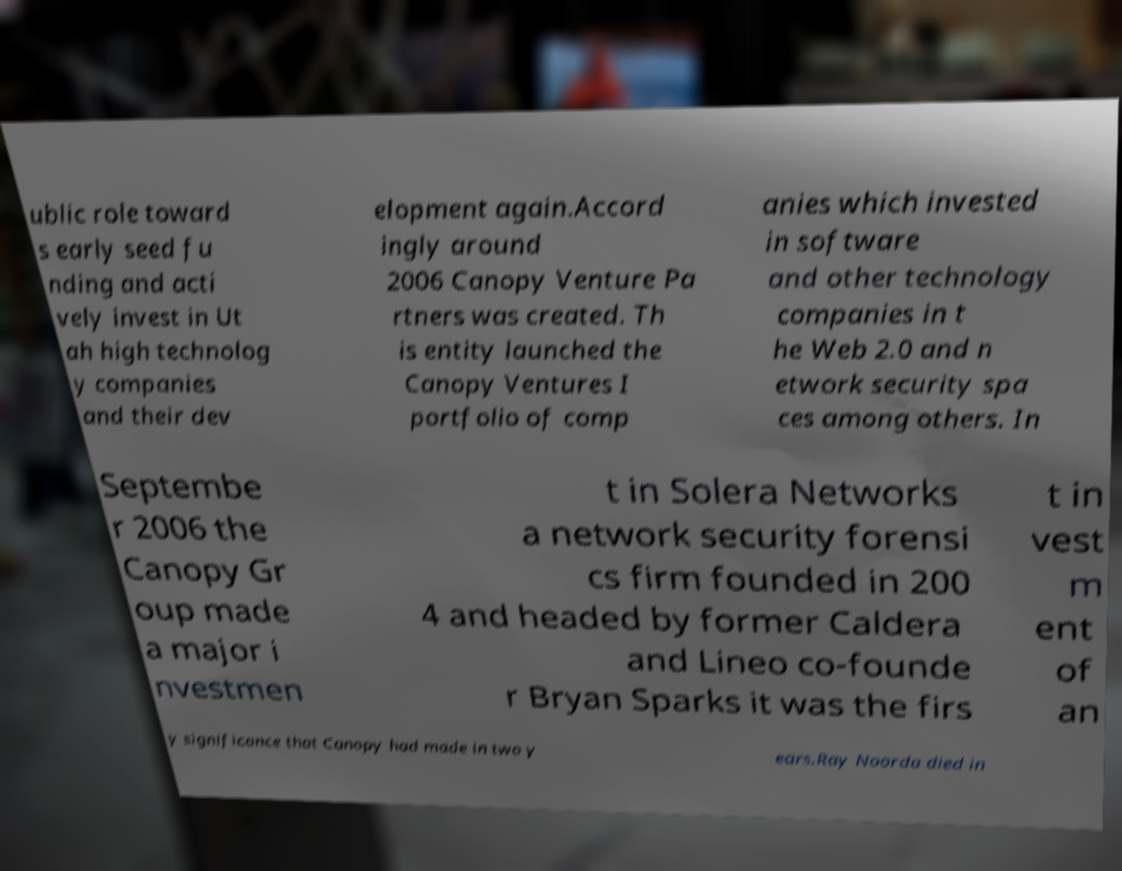For documentation purposes, I need the text within this image transcribed. Could you provide that? ublic role toward s early seed fu nding and acti vely invest in Ut ah high technolog y companies and their dev elopment again.Accord ingly around 2006 Canopy Venture Pa rtners was created. Th is entity launched the Canopy Ventures I portfolio of comp anies which invested in software and other technology companies in t he Web 2.0 and n etwork security spa ces among others. In Septembe r 2006 the Canopy Gr oup made a major i nvestmen t in Solera Networks a network security forensi cs firm founded in 200 4 and headed by former Caldera and Lineo co-founde r Bryan Sparks it was the firs t in vest m ent of an y significance that Canopy had made in two y ears.Ray Noorda died in 